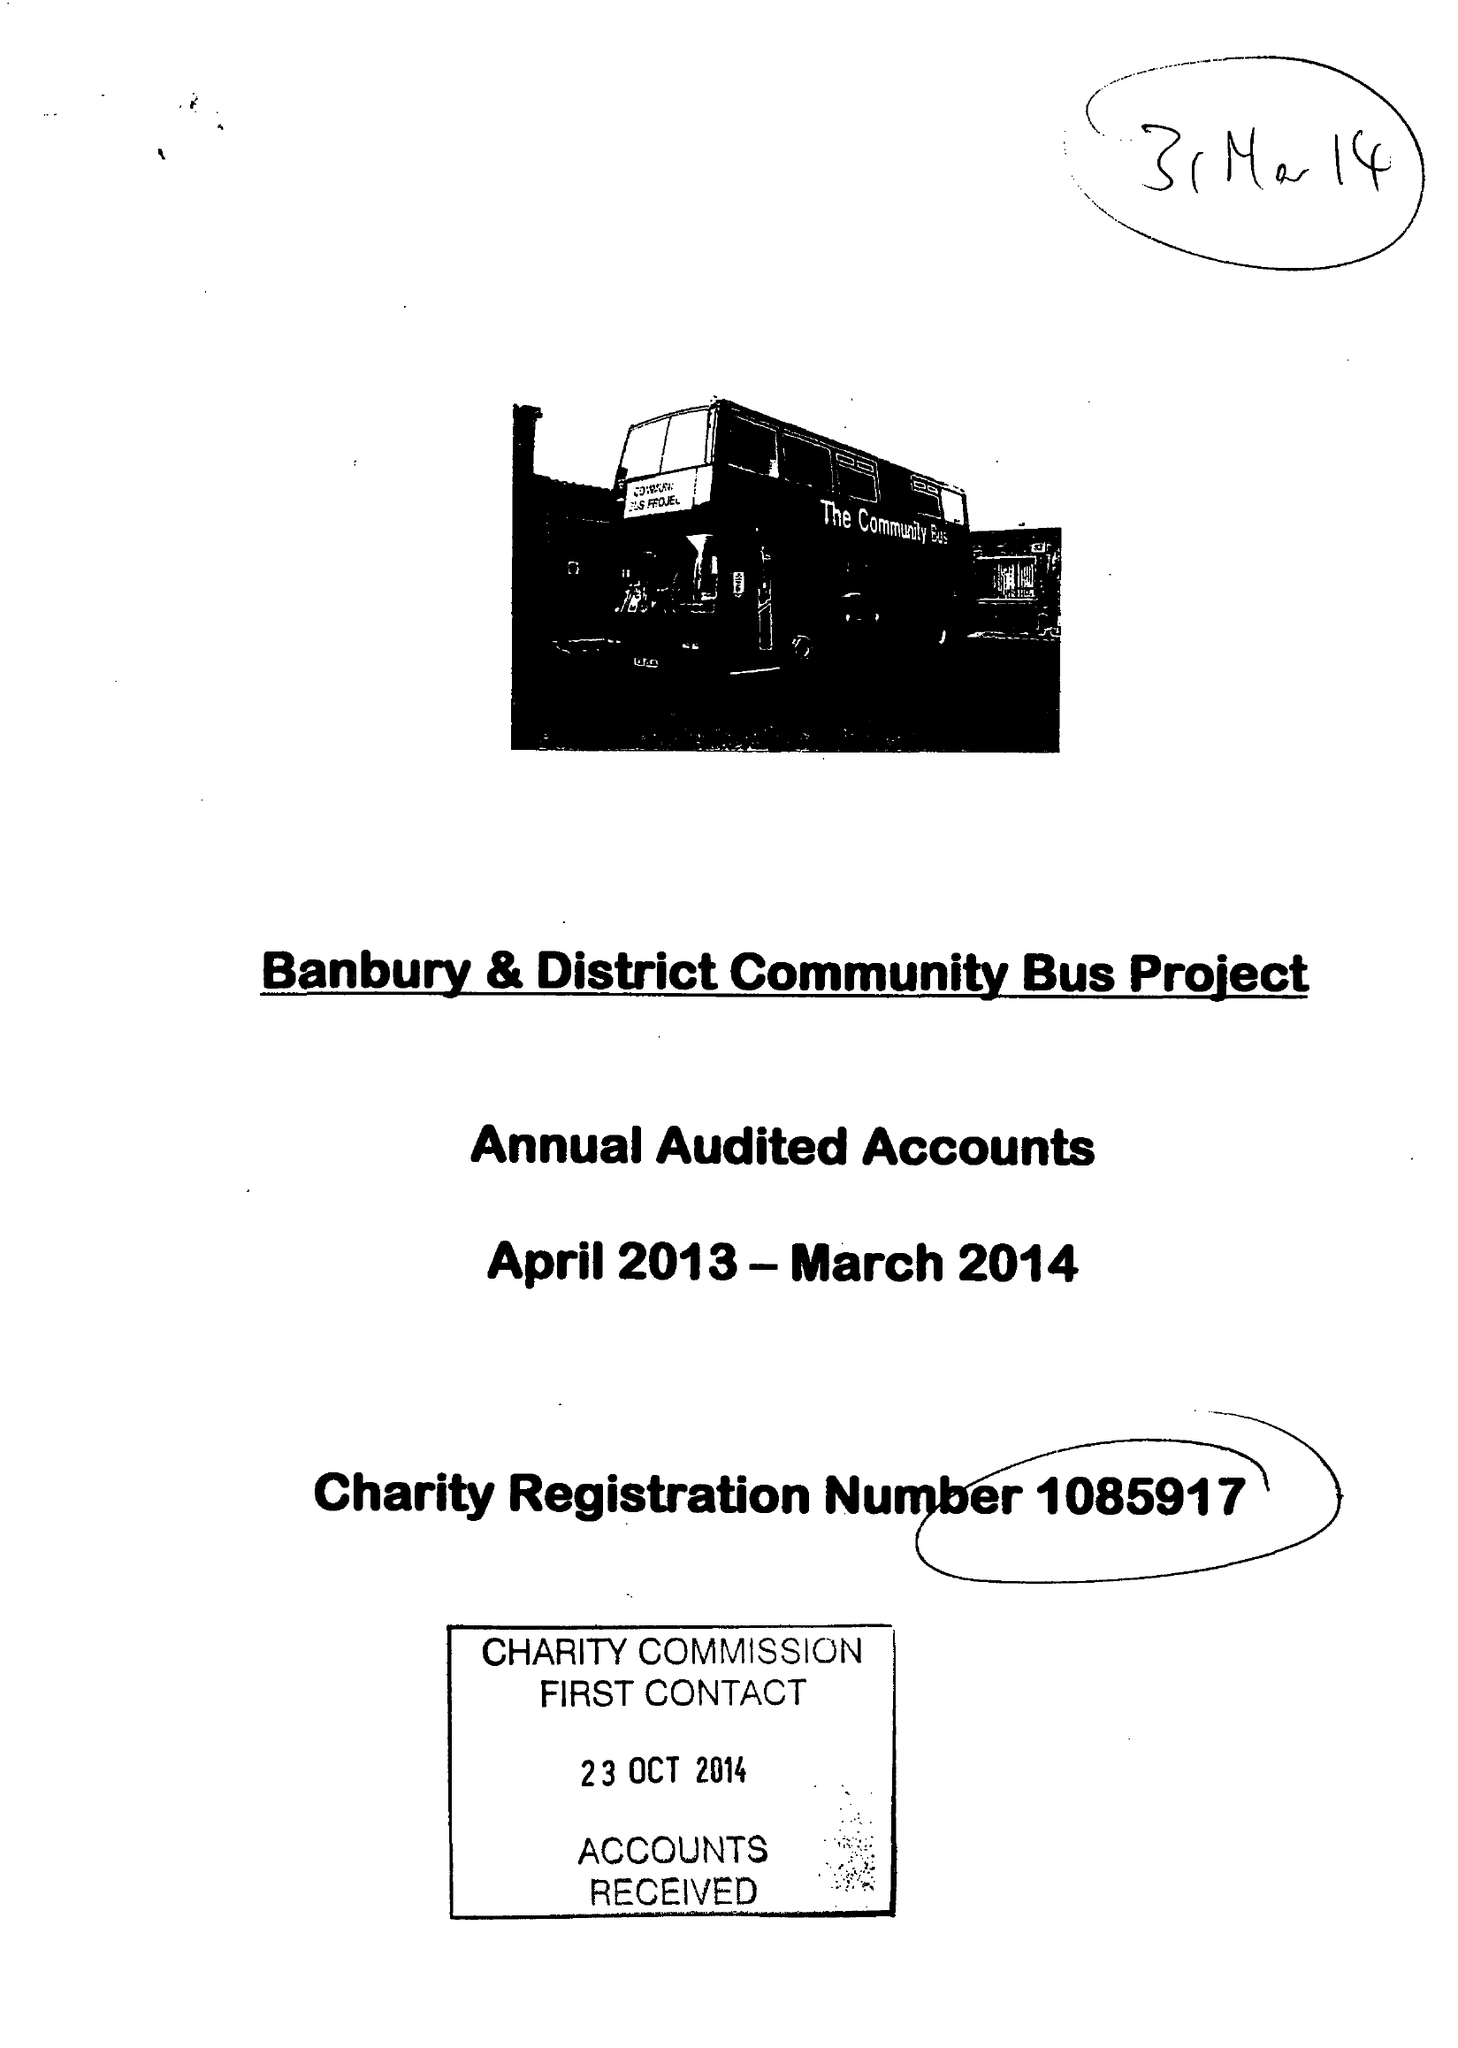What is the value for the report_date?
Answer the question using a single word or phrase. 2014-03-31 